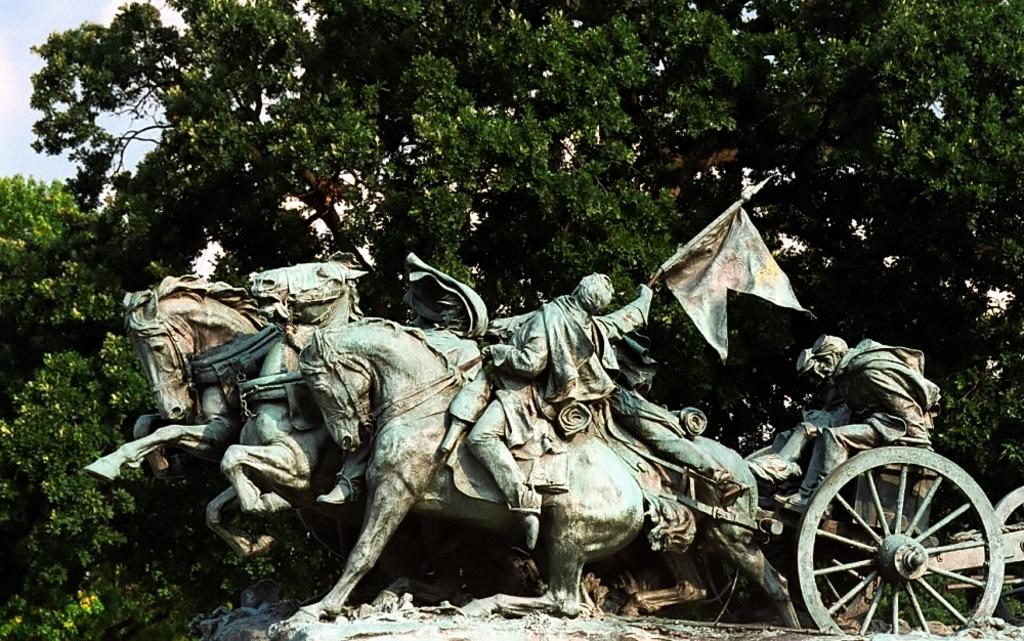What is the main subject in the image? There is a sculpture in the image. What can be seen in the background of the image? There are trees and the sky visible in the background of the image. What type of rail can be seen supporting the sculpture in the image? There is no rail present in the image; the sculpture is not supported by any rail. What type of twig is entwined around the branches of the trees in the background? There is no twig entwined around the branches of the trees in the background; the trees are not described in such detail. 